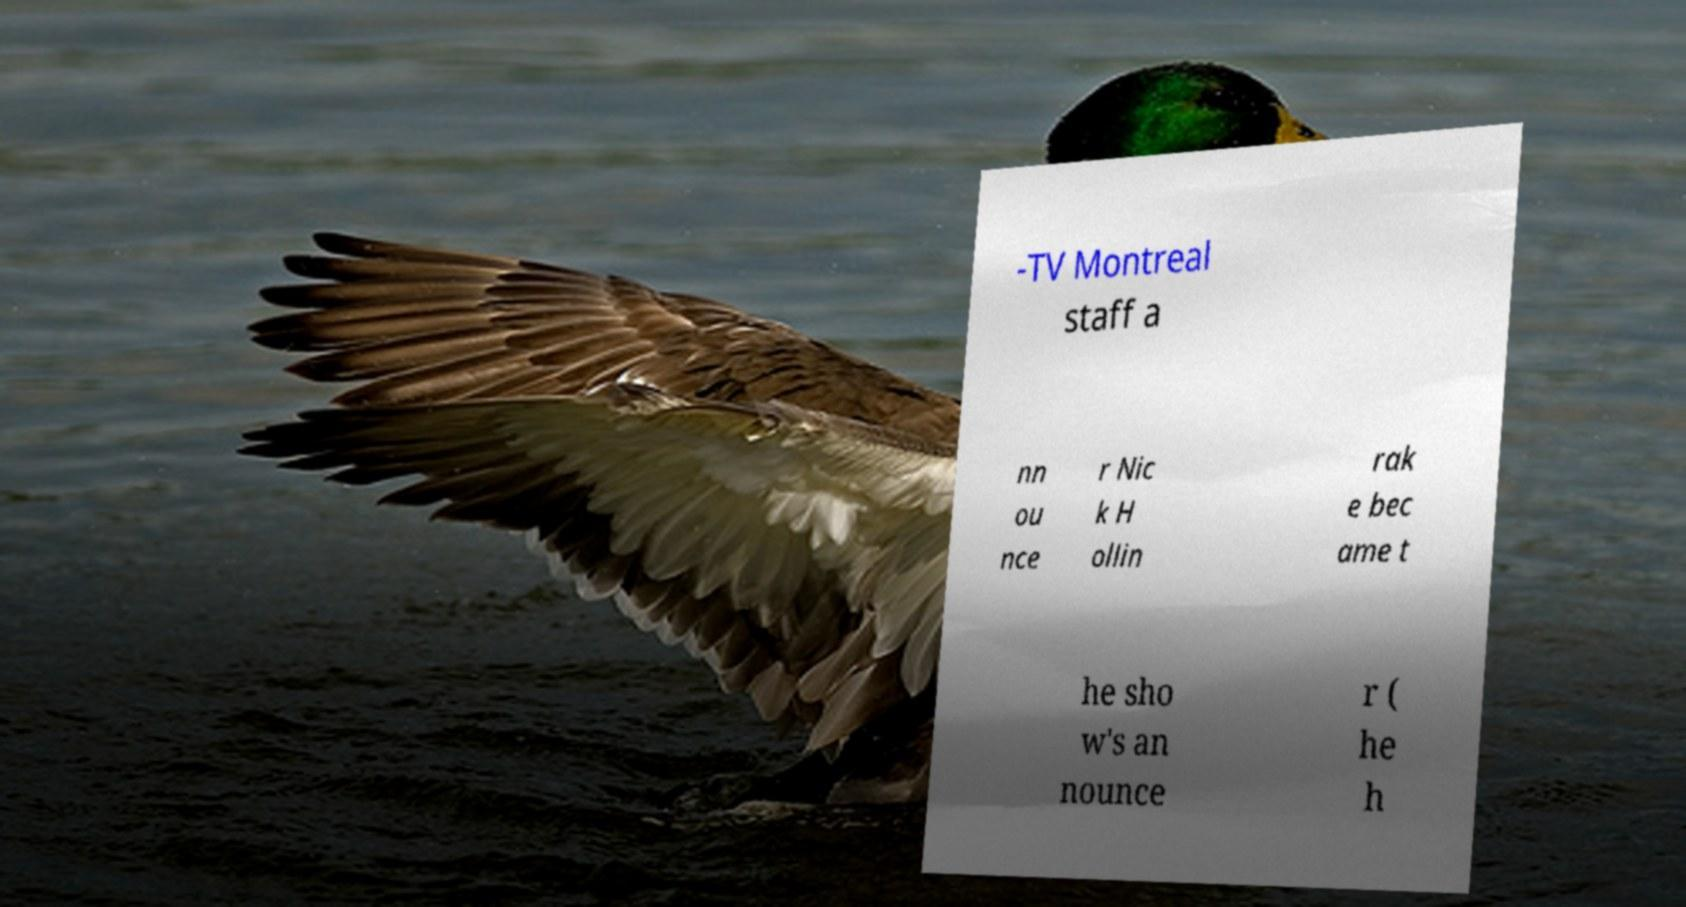Please identify and transcribe the text found in this image. -TV Montreal staff a nn ou nce r Nic k H ollin rak e bec ame t he sho w's an nounce r ( he h 